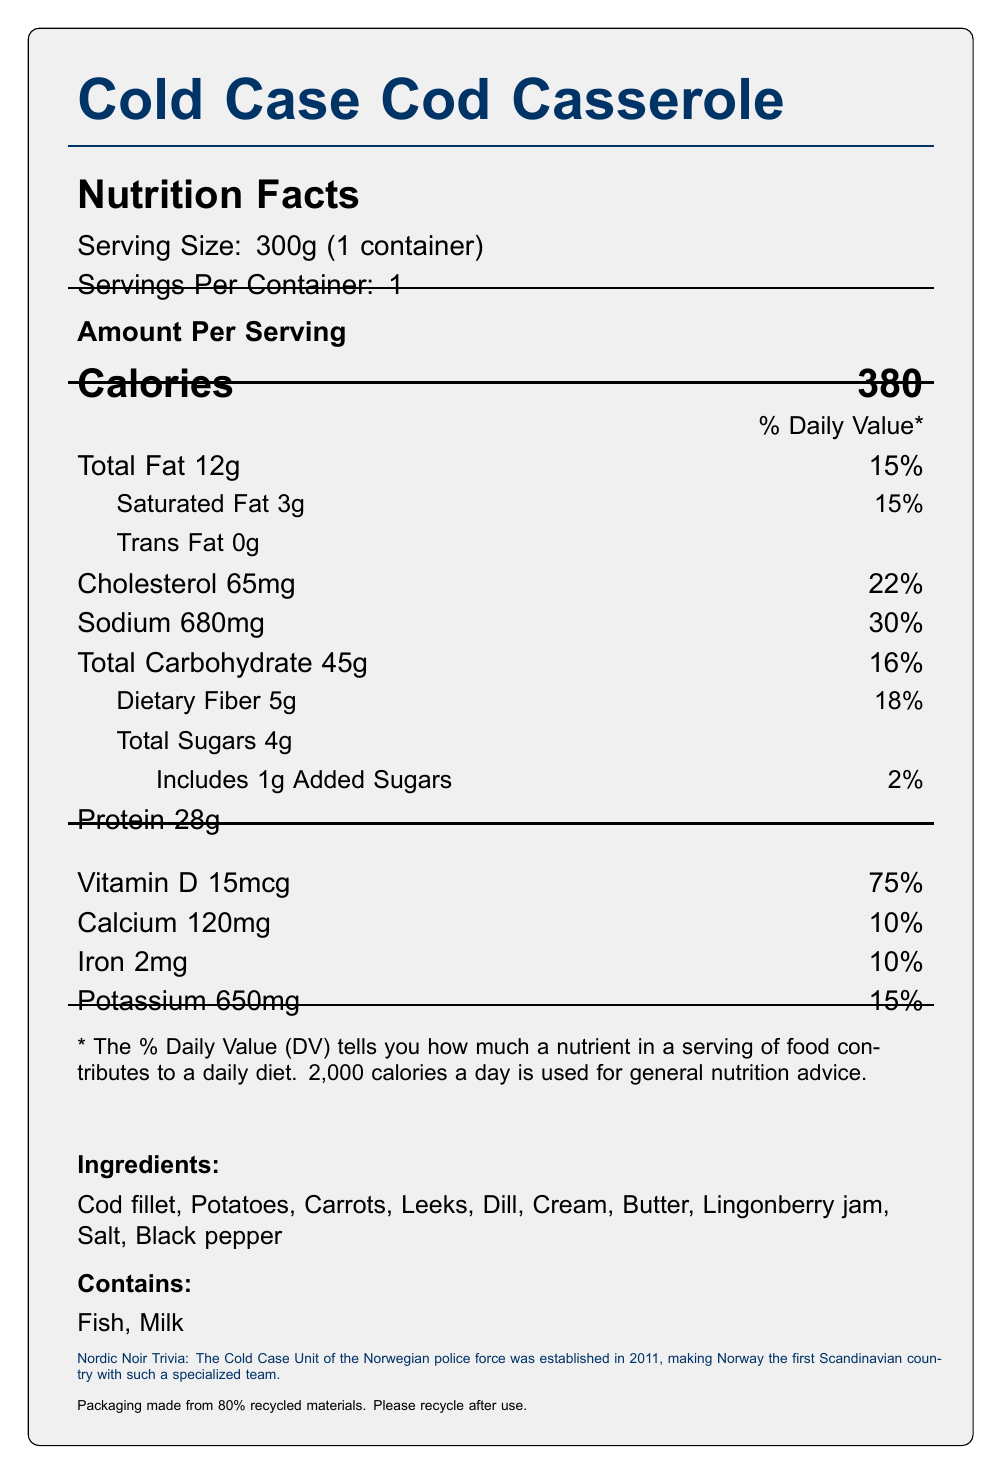what is the serving size of the "Cold Case Cod Casserole"? The document states the serving size as "300g (1 container)" near the top.
Answer: 300g (1 container) how many calories are in a serving of the "Cold Case Cod Casserole"? The number of calories per serving is listed as "380" under the "Calories" section.
Answer: 380 what is the total fat content in one serving of the casserole? The total fat content in one serving is listed as "Total Fat 12g."
Answer: 12g which ingredient is related to fish allergies? The ingredients list includes "Cod fillet," and the allergens listed are "Fish" and "Milk."
Answer: Cod fillet which vitamin is present in the highest percentage of daily value? The document lists Vitamin D at 75% daily value, which is higher compared to the other vitamins and minerals listed.
Answer: Vitamin D what are the main ingredients of the "Cold Case Cod Casserole"? The main ingredients are provided in the "Ingredients:" section of the document.
Answer: Cod fillet, Potatoes, Carrots, Leeks, Dill, Cream, Butter, Lingonberry jam, Salt, Black pepper how many Scandinavian crime-solving tips are included on the packaging? There are three crime-solving tips listed under the "crime_solving_tips" data in the document.
Answer: 3 how much cholesterol is in a serving? A. 35mg B. 50mg C. 65mg D. 80mg The document lists "Cholesterol 65mg" in the nutrition facts section.
Answer: C. 65mg what are the allergens contained in the casserole? A. Gluten and Nuts B. Fish and Milk C. Soy and Eggs D. Peanuts and Shellfish The document lists "Fish" and "Milk" under the "Contains:" section.
Answer: B. Fish and Milk does the casserole contain added sugars? The document lists "Includes 1g Added Sugars" under the section for Total Sugars.
Answer: Yes what crime-solving trivia or tip is included on the packaging? This is mentioned as the Nordic Noir trivia in the document.
Answer: The Cold Case Unit of the Norwegian police force was established in 2011, making Norway the first Scandinavian country with such a specialized team. describe the main idea of the document. The document covers various aspects like nutritional facts, ingredients, and thematic elements related to Scandinavian crime-solving.
Answer: The document provides detailed nutritional information, ingredients, allergens, preparation instructions, sustainability notes, and additional trivia about Scandinavian crime fiction and crime-solving tips for the "Cold Case Cod Casserole" frozen meal. how many servings are in each container of the "Cold Case Cod Casserole"? The document states "Servings Per Container: 1."
Answer: 1 which country established the first dedicated Cold Case Unit in Scandinavia? The trivia section states that Norway established the first dedicated Cold Case Unit in 2011.
Answer: Norway what is the total carbohydrate content per serving? The document lists "Total Carbohydrate 45g" in the nutritional information section.
Answer: 45g what was the purpose of establishing the Norwegian police force in 1859? The document mentions the establishment of the Norwegian police force in 1859 but does not provide a specific purpose for its establishment.
Answer: Cannot be determined 